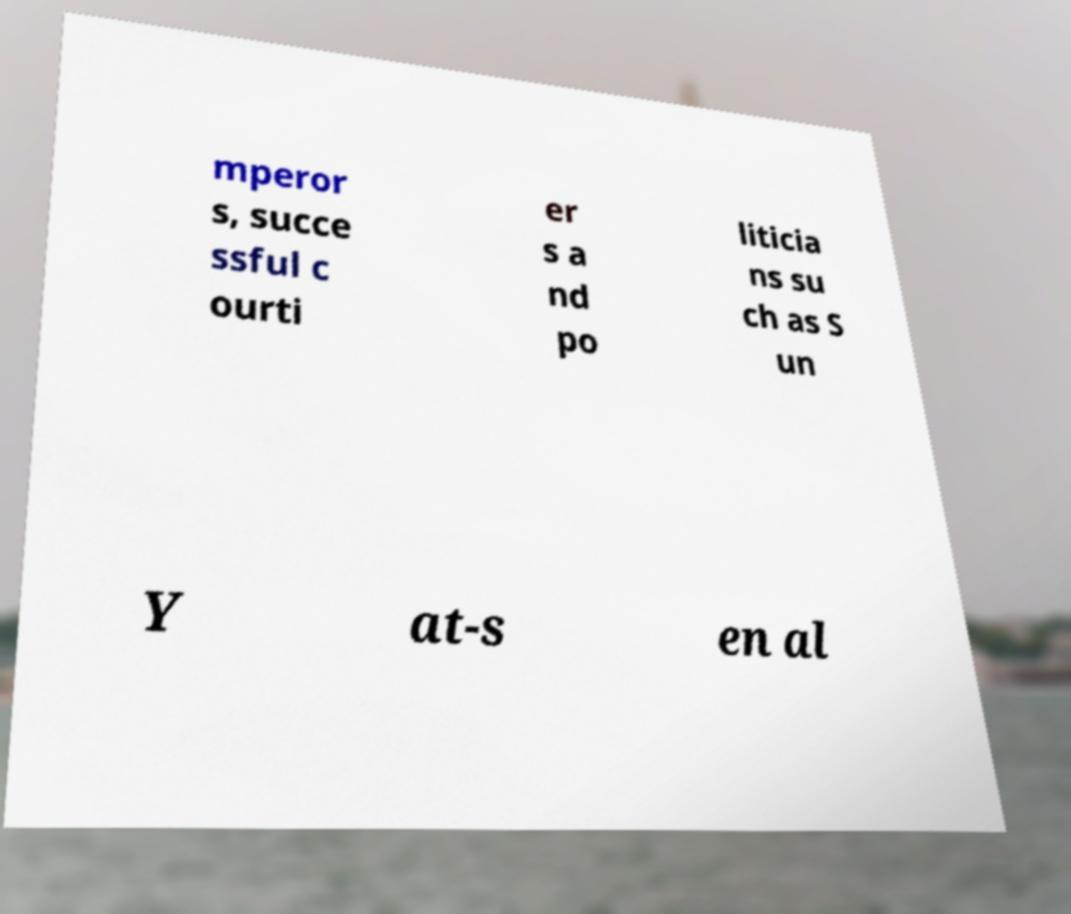I need the written content from this picture converted into text. Can you do that? mperor s, succe ssful c ourti er s a nd po liticia ns su ch as S un Y at-s en al 